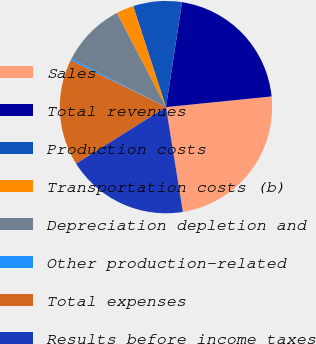Convert chart to OTSL. <chart><loc_0><loc_0><loc_500><loc_500><pie_chart><fcel>Sales<fcel>Total revenues<fcel>Production costs<fcel>Transportation costs (b)<fcel>Depreciation depletion and<fcel>Other production-related<fcel>Total expenses<fcel>Results before income taxes<nl><fcel>24.06%<fcel>20.98%<fcel>7.41%<fcel>2.66%<fcel>9.79%<fcel>0.28%<fcel>16.22%<fcel>18.6%<nl></chart> 